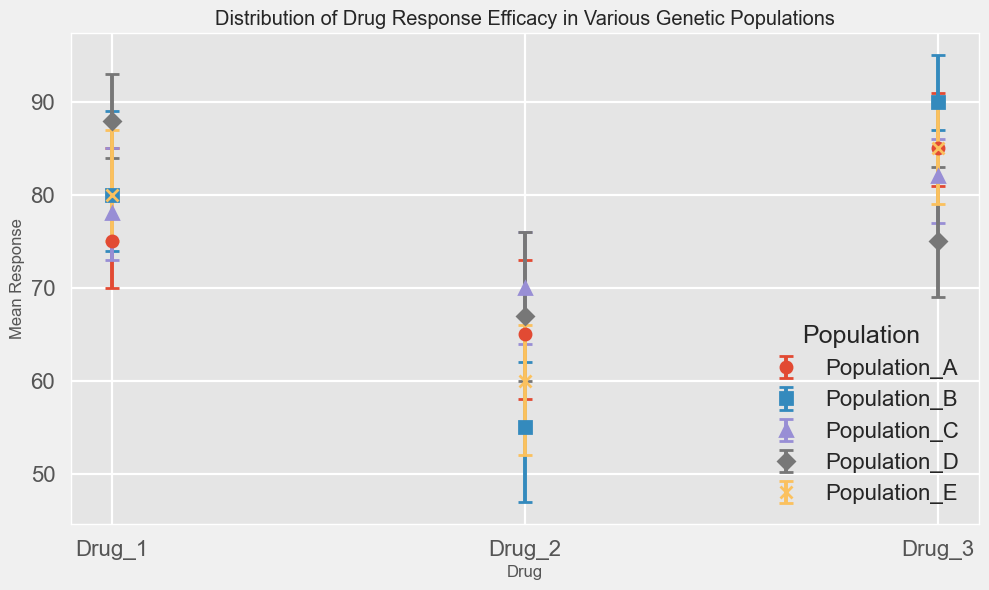Which population has the highest mean response to Drug 3? By examining the mean response values for Drug 3 across all populations, we see that Population B has a mean response of 90, which is the highest.
Answer: Population B Which drug has the smallest average error margin across all populations? To find the drug with the smallest average error margin across all populations, calculate the average error (upper + lower) / 2 for each drug, then compare these averages. Drug 2 has an average error margin of (7+8 + 8+7 + 6+6 + 7+9 + 8+6)/5 = 8.1, Drug 1 has 6.6, and Drug 3 has an average error margin of 5.6. Thus, Drug 3 has the smallest average error margin.
Answer: Drug 3 Which population shows the most variable response to Drug 2? Variability can be interpreted by larger error margins. Looking at the error margins for Drug 2, Population A has (7+8)/2 = 7.5, Population B has (8+7)/2 = 7.5, Population C has (6+6)/2 = 6, Population D has (7+9)/2 = 8, and Population E has (8+6)/2 = 7. Thus, Population D shows the most variable response with an average error of 8.
Answer: Population D What is the mean response range for Drugs 1 and 3 in Population C? For Drug 1 in Population C, the mean response is 78, and for Drug 3, it is 82. The range is from the minimum (78) to the maximum (82), so the range is 82 - 78 = 4.
Answer: 4 Is there a population where the mean response to Drug 1 is higher than Drug 3? We compare the mean responses of Drug 1 and Drug 3 within each population. Populations A, B, and E have higher responses for Drug 3 than Drug 1, and Population C has 78 for Drug 1 and 82 for Drug 3. Population D is the only one where Drug 1 has a higher response (88) compared to Drug 3 (75).
Answer: Yes, Population D What is the total upper error for all populations for Drug 1? The upper errors for Drug 1 across all populations are 10 for A, 9 for B, 7 for C, 5 for D, and 7 for E. Adding these gives 10 + 9 + 7 + 5 + 7 = 38.
Answer: 38 